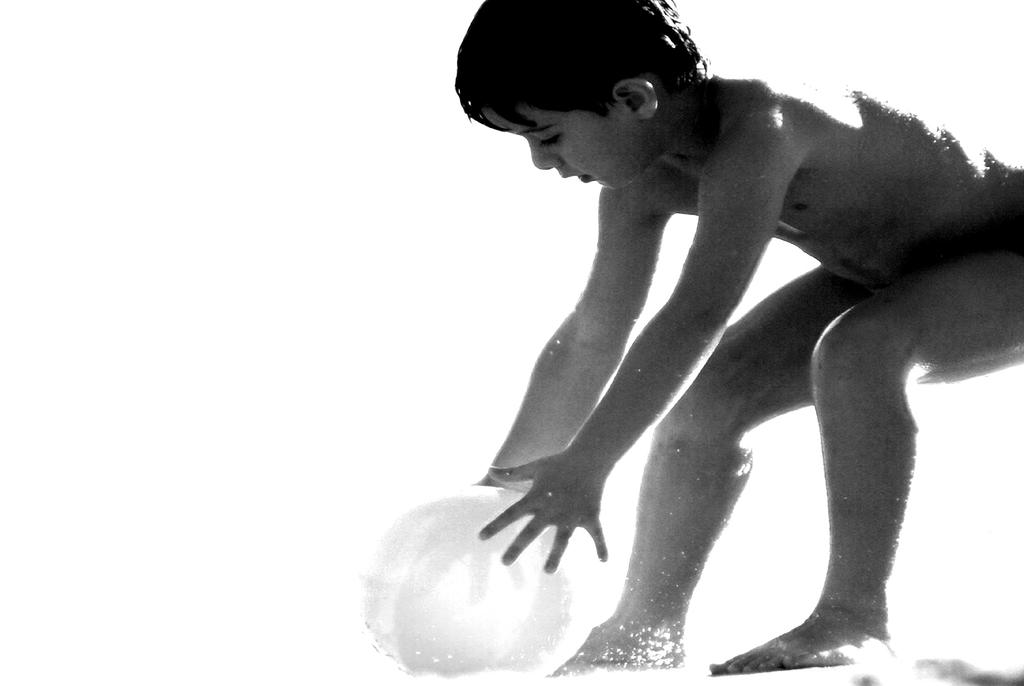What is the main subject of the image? The main subject of the image is a kid. What is the kid holding in the image? The kid is holding a ball. What type of quilt is visible on the front of the kid in the image? There is no quilt visible on the kid in the image; the kid is holding a ball. 